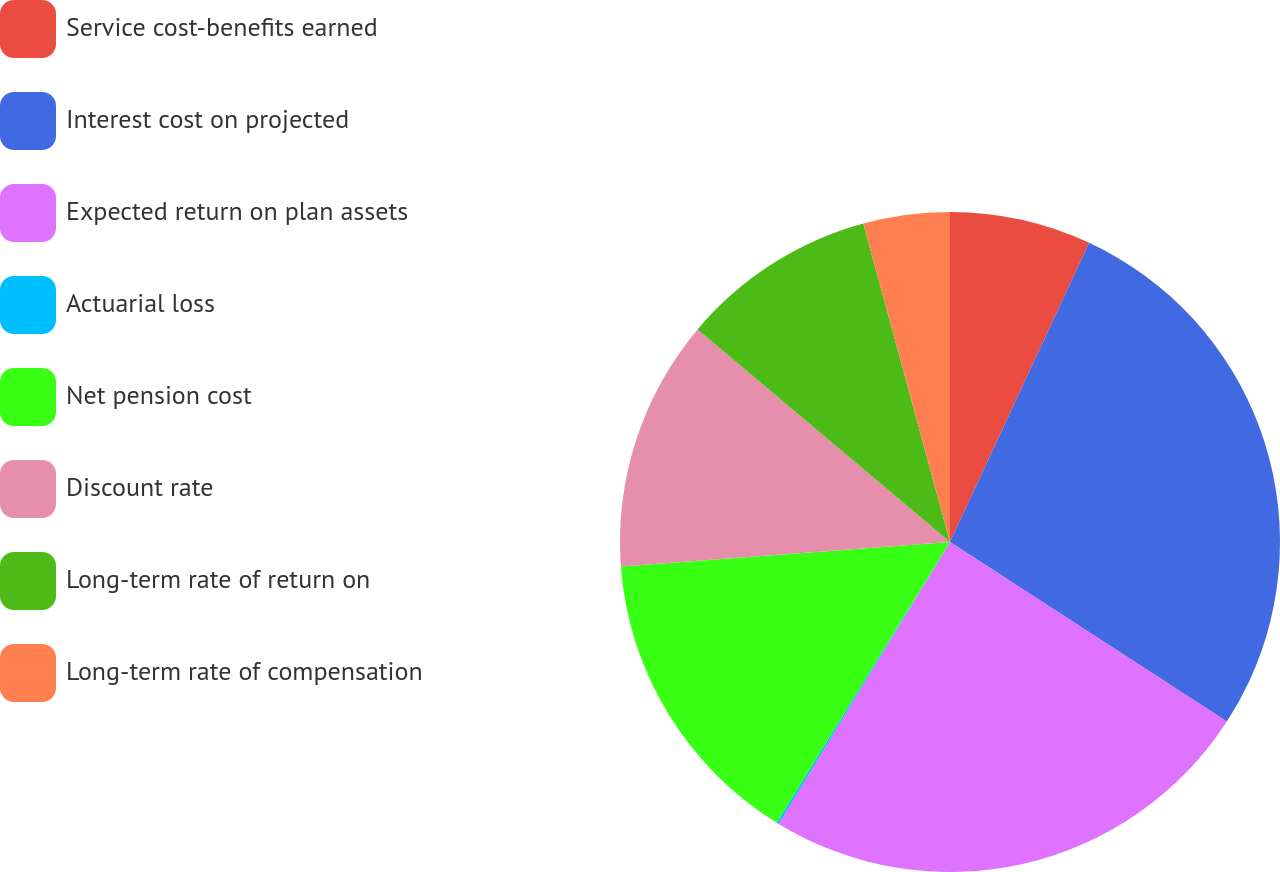Convert chart. <chart><loc_0><loc_0><loc_500><loc_500><pie_chart><fcel>Service cost-benefits earned<fcel>Interest cost on projected<fcel>Expected return on plan assets<fcel>Actuarial loss<fcel>Net pension cost<fcel>Discount rate<fcel>Long-term rate of return on<fcel>Long-term rate of compensation<nl><fcel>6.93%<fcel>27.23%<fcel>24.53%<fcel>0.11%<fcel>15.02%<fcel>12.32%<fcel>9.63%<fcel>4.23%<nl></chart> 